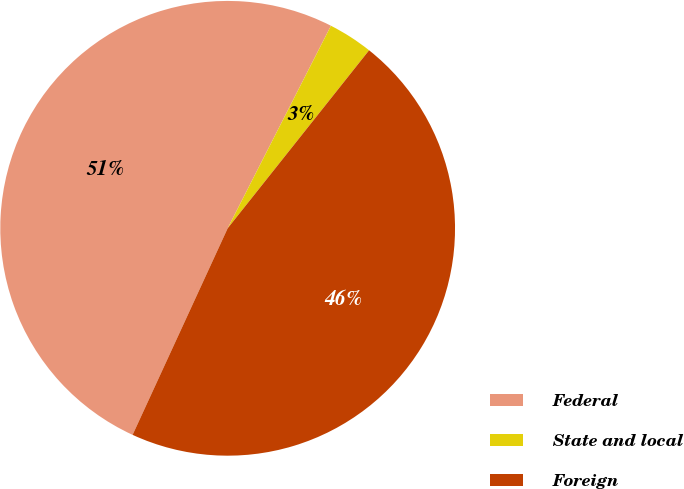Convert chart to OTSL. <chart><loc_0><loc_0><loc_500><loc_500><pie_chart><fcel>Federal<fcel>State and local<fcel>Foreign<nl><fcel>50.64%<fcel>3.18%<fcel>46.18%<nl></chart> 